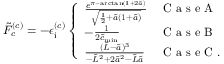<formula> <loc_0><loc_0><loc_500><loc_500>\tilde { F } _ { c } ^ { ( c ) } = - \epsilon _ { i } ^ { ( c ) } \left \{ \begin{array} { l l } { \frac { e ^ { \pi - \arctan ( 1 + 2 \tilde { a } ) } } { \sqrt { \frac { 1 } { 2 } + \tilde { a } ( 1 + \tilde { a } ) } } } & { C a s e A } \\ { - \frac { 1 } { 2 \tilde { c } _ { \min } } } & { C a s e B } \\ { \frac { ( \tilde { L } - \tilde { a } ) ^ { 3 } } { - \tilde { L } ^ { 2 } + 2 \tilde { a } ^ { 2 } - \tilde { L } \tilde { a } } } & { C a s e C . } \end{array}</formula> 